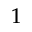<formula> <loc_0><loc_0><loc_500><loc_500>1</formula> 